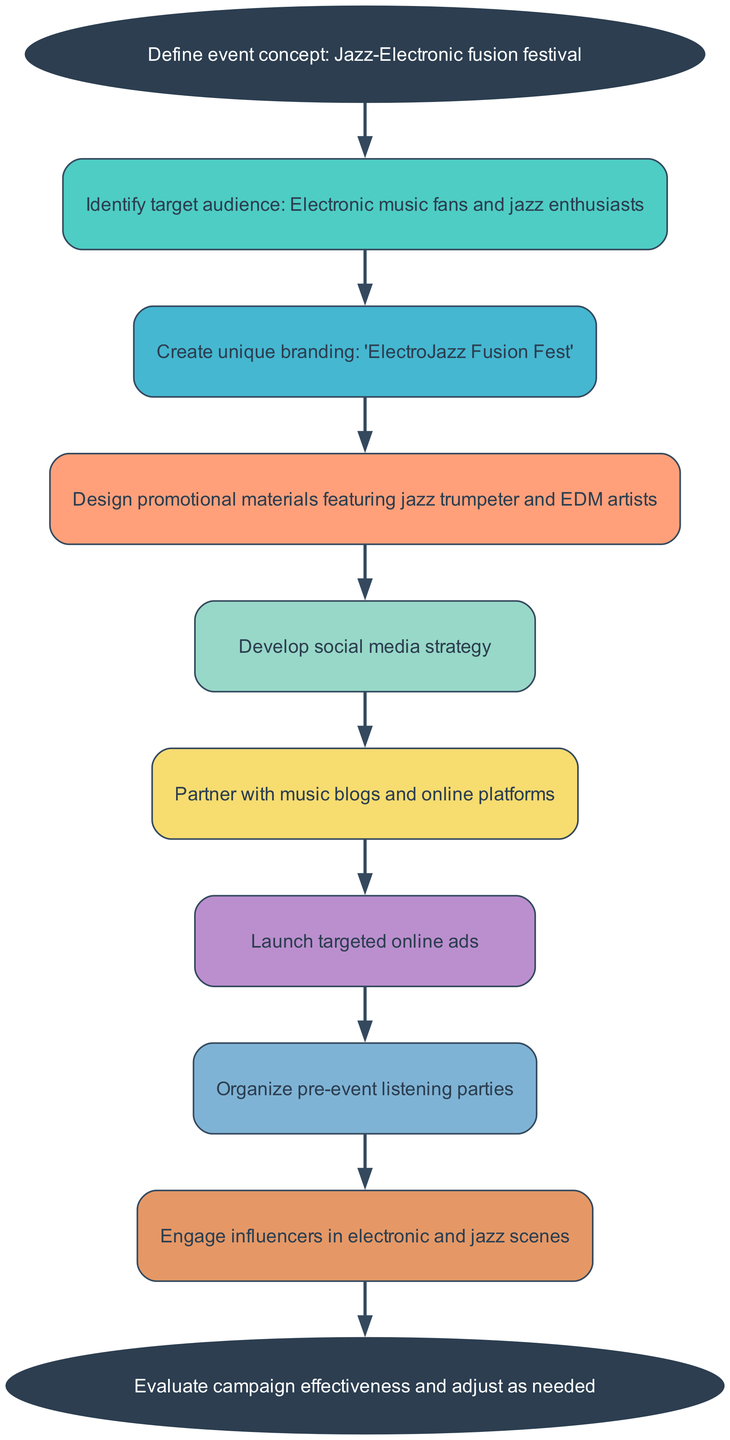What is the first step in the marketing campaign? The first step is defined in the 'start' node, which is to "Define event concept: Jazz-Electronic fusion festival." This indicates what the campaign is fundamentally about.
Answer: Define event concept: Jazz-Electronic fusion festival How many promotional materials are designed in the campaign? The diagram clearly shows the node that states "Design promotional materials featuring jazz trumpeter and EDM artists," indicating that promotional materials are part of the process but does not quantify them. Therefore, we conclude that there is one critical step for designing promotional materials.
Answer: 1 What follows after identifying the target audience? By tracing the arrows from the 'Identifying target audience' node to the next node, we see that it proceeds to "Create unique branding: 'ElectroJazz Fusion Fest'." Thus, creating unique branding directly follows identifying the target audience in the flow of the campaign.
Answer: Create unique branding: 'ElectroJazz Fusion Fest' Which step involves engaging influencers? In the diagram, the node that corresponds to engaging influencers is "Engage influencers in electronic and jazz scenes." This can be found at the end of the flow before evaluating the campaign effectiveness.
Answer: Engage influencers in electronic and jazz scenes What is the last action taken in the campaign process? The last node in the flow chart is "Evaluate campaign effectiveness and adjust as needed," signifying that the campaign's final action is evaluation. This is the very end of the instructional flow.
Answer: Evaluate campaign effectiveness and adjust as needed What connects the step of developing social media strategy to partnering with music blogs? The diagram indicates that "Develop social media strategy" directly points to the next step, which is "Partner with music blogs and online platforms." Thus, the connection shows that after developing a social media strategy, the next logical step is partnering with music blogs.
Answer: Partner with music blogs and online platforms 